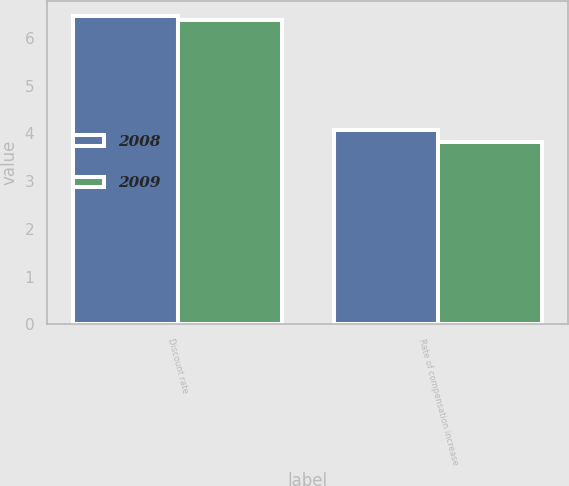Convert chart. <chart><loc_0><loc_0><loc_500><loc_500><stacked_bar_chart><ecel><fcel>Discount rate<fcel>Rate of compensation increase<nl><fcel>2008<fcel>6.45<fcel>4.06<nl><fcel>2009<fcel>6.37<fcel>3.81<nl></chart> 